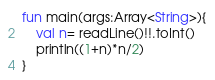Convert code to text. <code><loc_0><loc_0><loc_500><loc_500><_Kotlin_>fun main(args:Array<String>){
    val n= readLine()!!.toInt()
    println((1+n)*n/2)
}
</code> 